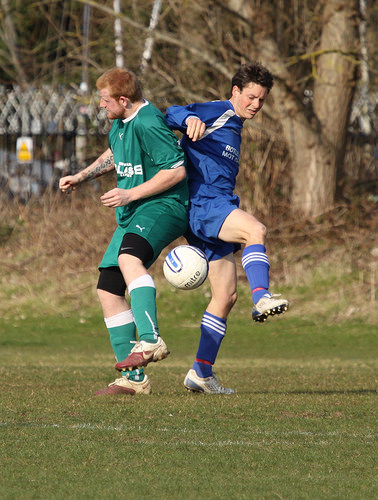<image>
Is the man in front of the ball? No. The man is not in front of the ball. The spatial positioning shows a different relationship between these objects. 